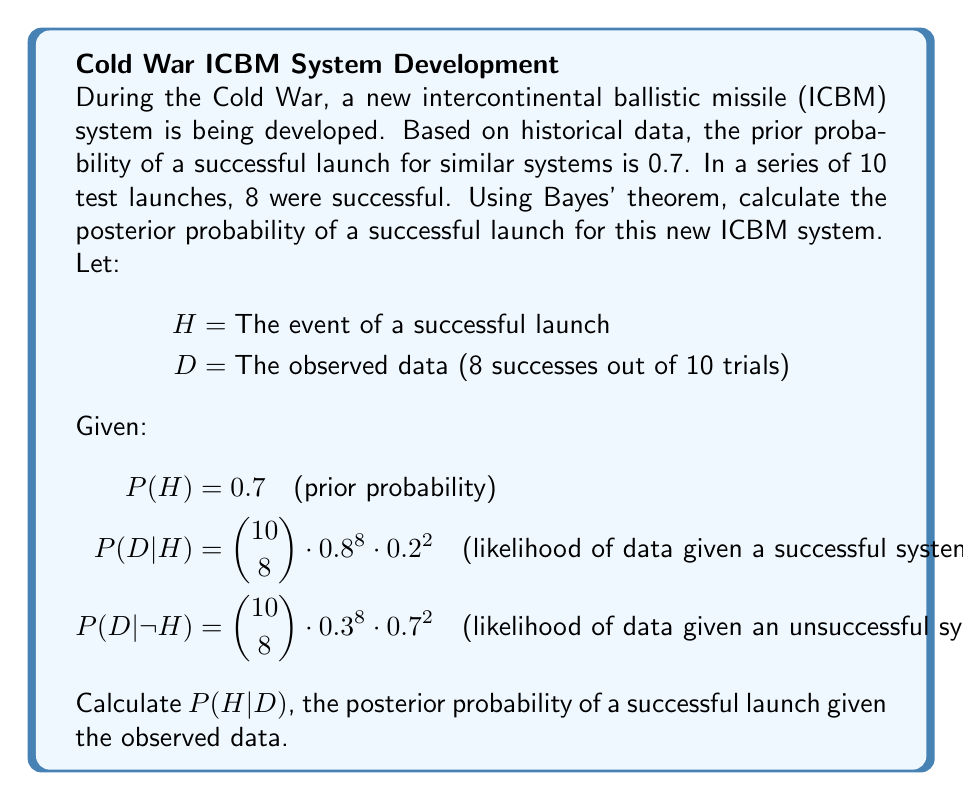Can you solve this math problem? To solve this problem, we'll use Bayes' theorem:

$$P(H|D) = \frac{P(D|H) \cdot P(H)}{P(D)}$$

Step 1: Calculate $P(D|H)$
$$P(D|H) = \binom{10}{8} \cdot 0.8^8 \cdot 0.2^2 = 45 \cdot 0.16777216 \cdot 0.04 = 0.3020$$

Step 2: Calculate $P(D|\neg H)$
$$P(D|\neg H) = \binom{10}{8} \cdot 0.3^8 \cdot 0.7^2 = 45 \cdot 0.00006561 \cdot 0.49 = 0.0001447$$

Step 3: Calculate $P(D)$ using the law of total probability
$$P(D) = P(D|H) \cdot P(H) + P(D|\neg H) \cdot P(\neg H)$$
$$P(D) = 0.3020 \cdot 0.7 + 0.0001447 \cdot 0.3 = 0.2114 + 0.00004341 = 0.21144341$$

Step 4: Apply Bayes' theorem
$$P(H|D) = \frac{P(D|H) \cdot P(H)}{P(D)} = \frac{0.3020 \cdot 0.7}{0.21144341} = 0.9998$$

Therefore, the posterior probability of a successful launch given the observed data is approximately 0.9998 or 99.98%.
Answer: $P(H|D) \approx 0.9998$ 